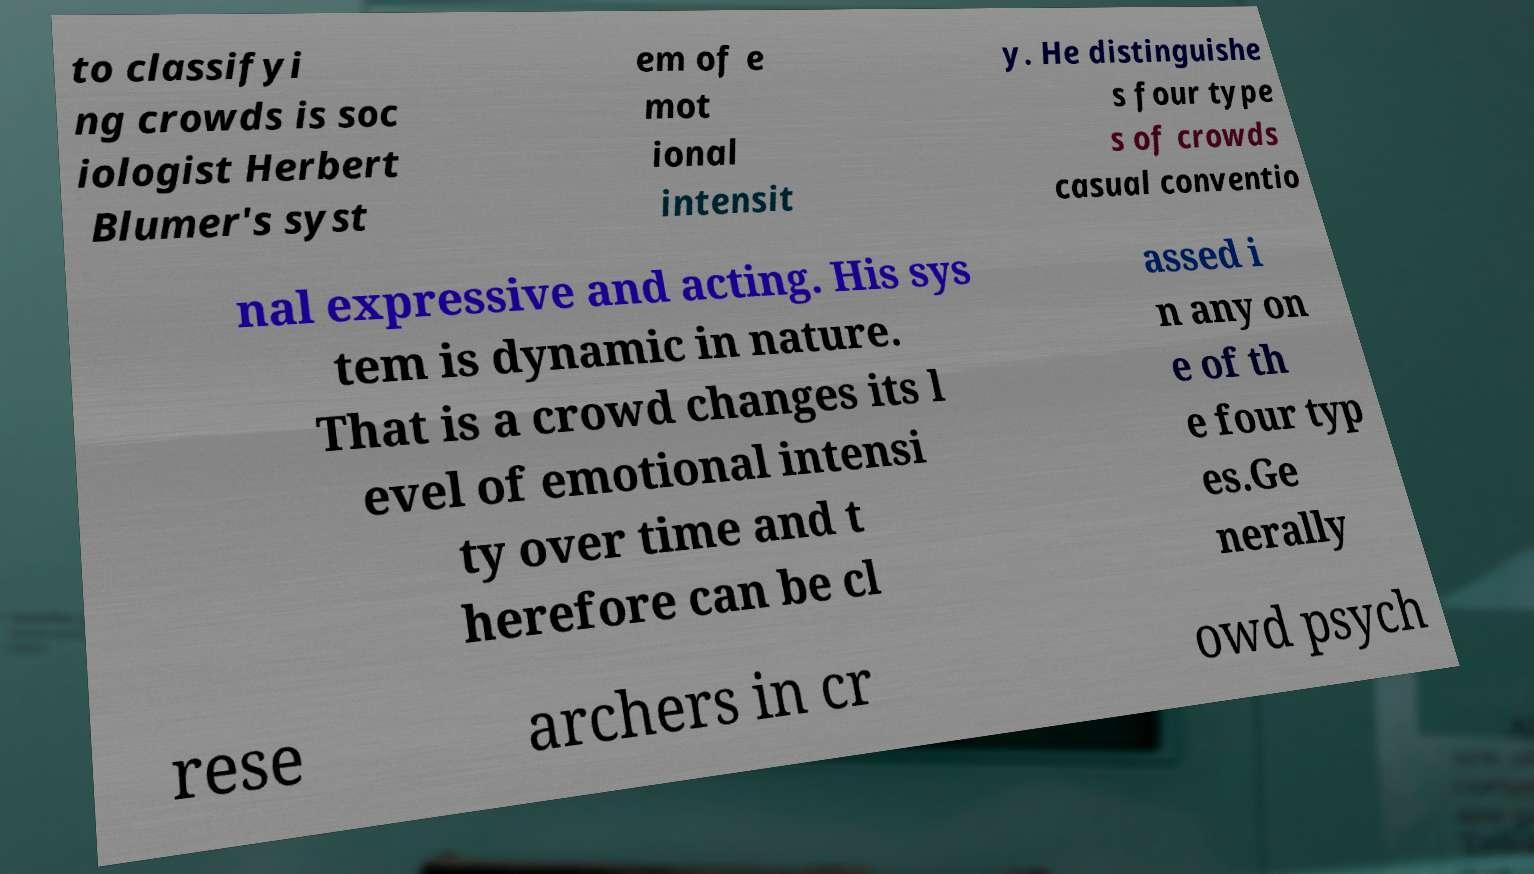Please identify and transcribe the text found in this image. to classifyi ng crowds is soc iologist Herbert Blumer's syst em of e mot ional intensit y. He distinguishe s four type s of crowds casual conventio nal expressive and acting. His sys tem is dynamic in nature. That is a crowd changes its l evel of emotional intensi ty over time and t herefore can be cl assed i n any on e of th e four typ es.Ge nerally rese archers in cr owd psych 